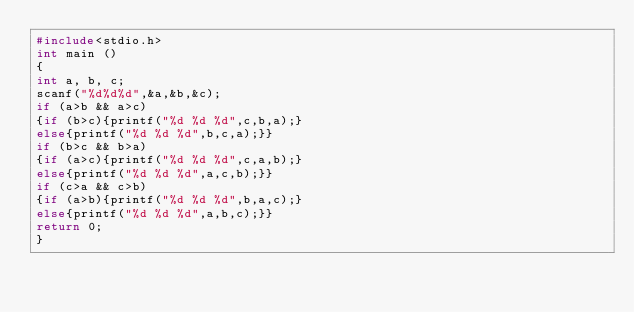Convert code to text. <code><loc_0><loc_0><loc_500><loc_500><_C_>#include<stdio.h>
int main ()
{
int a, b, c;
scanf("%d%d%d",&a,&b,&c);
if (a>b && a>c)
{if (b>c){printf("%d %d %d",c,b,a);}
else{printf("%d %d %d",b,c,a);}}
if (b>c && b>a)
{if (a>c){printf("%d %d %d",c,a,b);}
else{printf("%d %d %d",a,c,b);}}
if (c>a && c>b)
{if (a>b){printf("%d %d %d",b,a,c);}
else{printf("%d %d %d",a,b,c);}}
return 0;
}</code> 